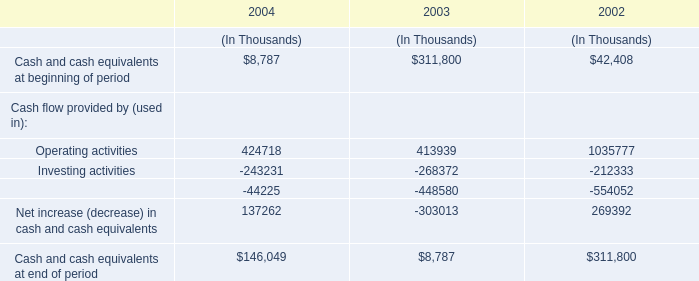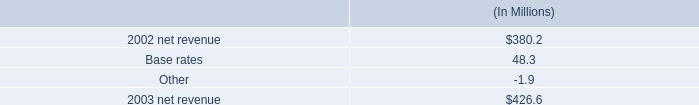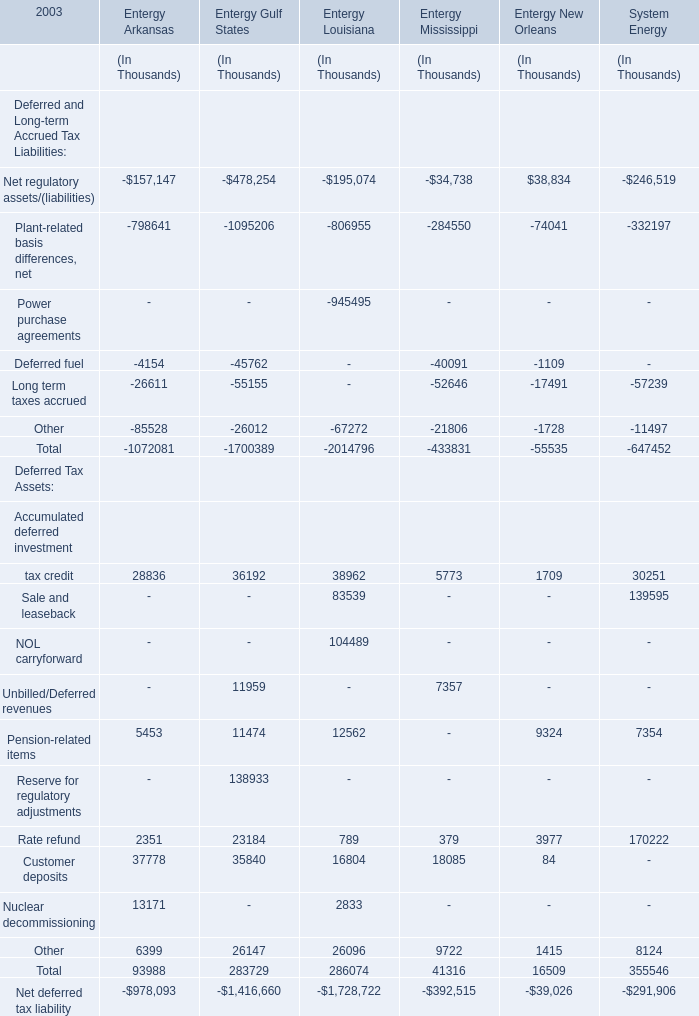What do all Entergy Arkansas sum up without those Entergy Arkansas smaller than0, in 2003? (in thousand) 
Computations: (((((28836 + 5453) + 2351) + 37778) + 13171) + 6399)
Answer: 93988.0. 